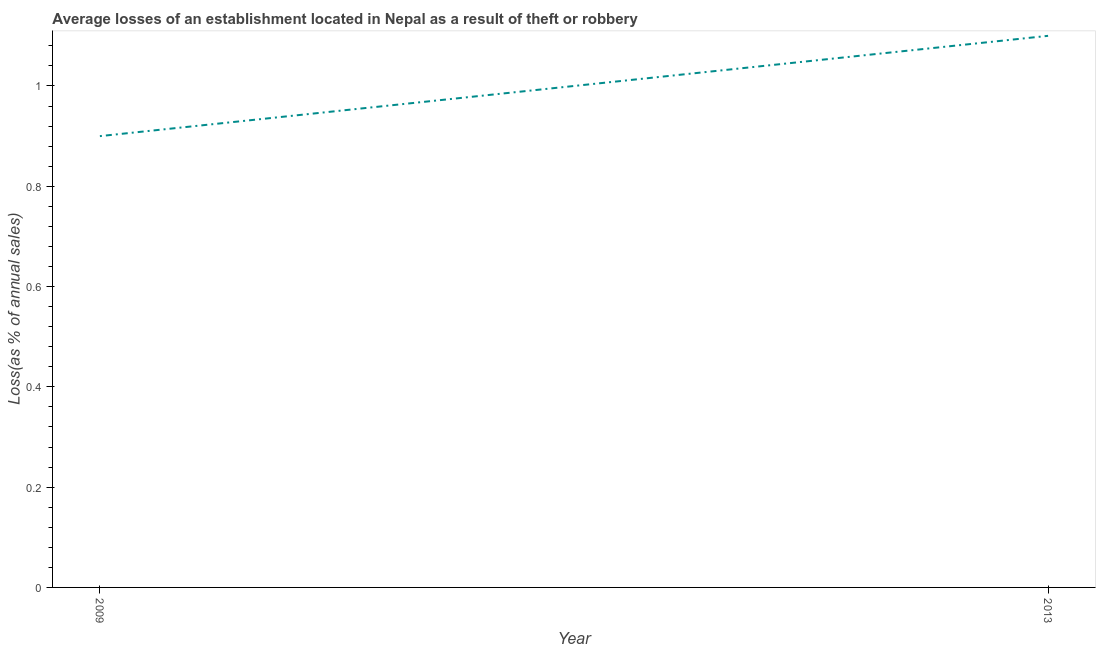In which year was the losses due to theft maximum?
Make the answer very short. 2013. In which year was the losses due to theft minimum?
Your answer should be very brief. 2009. What is the difference between the losses due to theft in 2009 and 2013?
Give a very brief answer. -0.2. In how many years, is the losses due to theft greater than 1 %?
Your answer should be very brief. 1. Do a majority of the years between 2013 and 2009 (inclusive) have losses due to theft greater than 0.12 %?
Provide a succinct answer. No. What is the ratio of the losses due to theft in 2009 to that in 2013?
Offer a terse response. 0.82. Is the losses due to theft in 2009 less than that in 2013?
Your answer should be very brief. Yes. How many lines are there?
Provide a succinct answer. 1. Are the values on the major ticks of Y-axis written in scientific E-notation?
Make the answer very short. No. Does the graph contain any zero values?
Provide a short and direct response. No. What is the title of the graph?
Give a very brief answer. Average losses of an establishment located in Nepal as a result of theft or robbery. What is the label or title of the Y-axis?
Give a very brief answer. Loss(as % of annual sales). What is the Loss(as % of annual sales) in 2009?
Your answer should be very brief. 0.9. What is the Loss(as % of annual sales) in 2013?
Give a very brief answer. 1.1. What is the difference between the Loss(as % of annual sales) in 2009 and 2013?
Ensure brevity in your answer.  -0.2. What is the ratio of the Loss(as % of annual sales) in 2009 to that in 2013?
Your response must be concise. 0.82. 